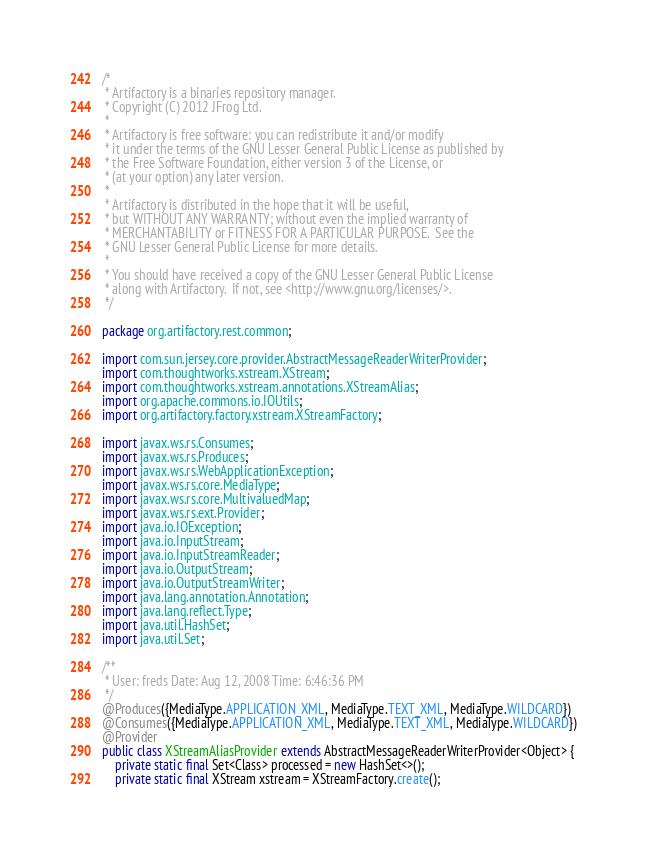Convert code to text. <code><loc_0><loc_0><loc_500><loc_500><_Java_>/*
 * Artifactory is a binaries repository manager.
 * Copyright (C) 2012 JFrog Ltd.
 *
 * Artifactory is free software: you can redistribute it and/or modify
 * it under the terms of the GNU Lesser General Public License as published by
 * the Free Software Foundation, either version 3 of the License, or
 * (at your option) any later version.
 *
 * Artifactory is distributed in the hope that it will be useful,
 * but WITHOUT ANY WARRANTY; without even the implied warranty of
 * MERCHANTABILITY or FITNESS FOR A PARTICULAR PURPOSE.  See the
 * GNU Lesser General Public License for more details.
 *
 * You should have received a copy of the GNU Lesser General Public License
 * along with Artifactory.  If not, see <http://www.gnu.org/licenses/>.
 */

package org.artifactory.rest.common;

import com.sun.jersey.core.provider.AbstractMessageReaderWriterProvider;
import com.thoughtworks.xstream.XStream;
import com.thoughtworks.xstream.annotations.XStreamAlias;
import org.apache.commons.io.IOUtils;
import org.artifactory.factory.xstream.XStreamFactory;

import javax.ws.rs.Consumes;
import javax.ws.rs.Produces;
import javax.ws.rs.WebApplicationException;
import javax.ws.rs.core.MediaType;
import javax.ws.rs.core.MultivaluedMap;
import javax.ws.rs.ext.Provider;
import java.io.IOException;
import java.io.InputStream;
import java.io.InputStreamReader;
import java.io.OutputStream;
import java.io.OutputStreamWriter;
import java.lang.annotation.Annotation;
import java.lang.reflect.Type;
import java.util.HashSet;
import java.util.Set;

/**
 * User: freds Date: Aug 12, 2008 Time: 6:46:36 PM
 */
@Produces({MediaType.APPLICATION_XML, MediaType.TEXT_XML, MediaType.WILDCARD})
@Consumes({MediaType.APPLICATION_XML, MediaType.TEXT_XML, MediaType.WILDCARD})
@Provider
public class XStreamAliasProvider extends AbstractMessageReaderWriterProvider<Object> {
    private static final Set<Class> processed = new HashSet<>();
    private static final XStream xstream = XStreamFactory.create();</code> 